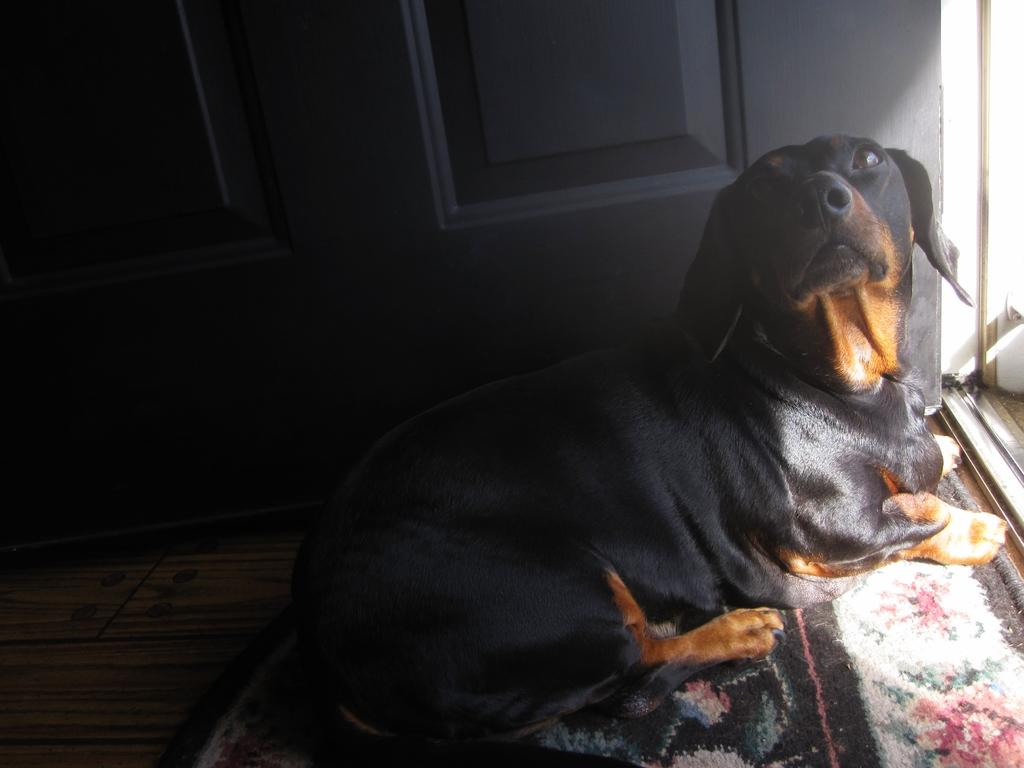What type of furniture is present in the image? There is a cupboard in the image. What type of animal can be seen in the image? There is a black color dog in the image. What is on the floor in the image? There is a mat on the floor in the image. What type of straw is the dog chewing on in the image? There is no straw present in the image; it features a black color dog. Can you tell me where the wilderness is located in the image? There is no wilderness present in the image. What type of hat is the dog wearing in the image? There is no hat present in the image; it features a black color dog. 